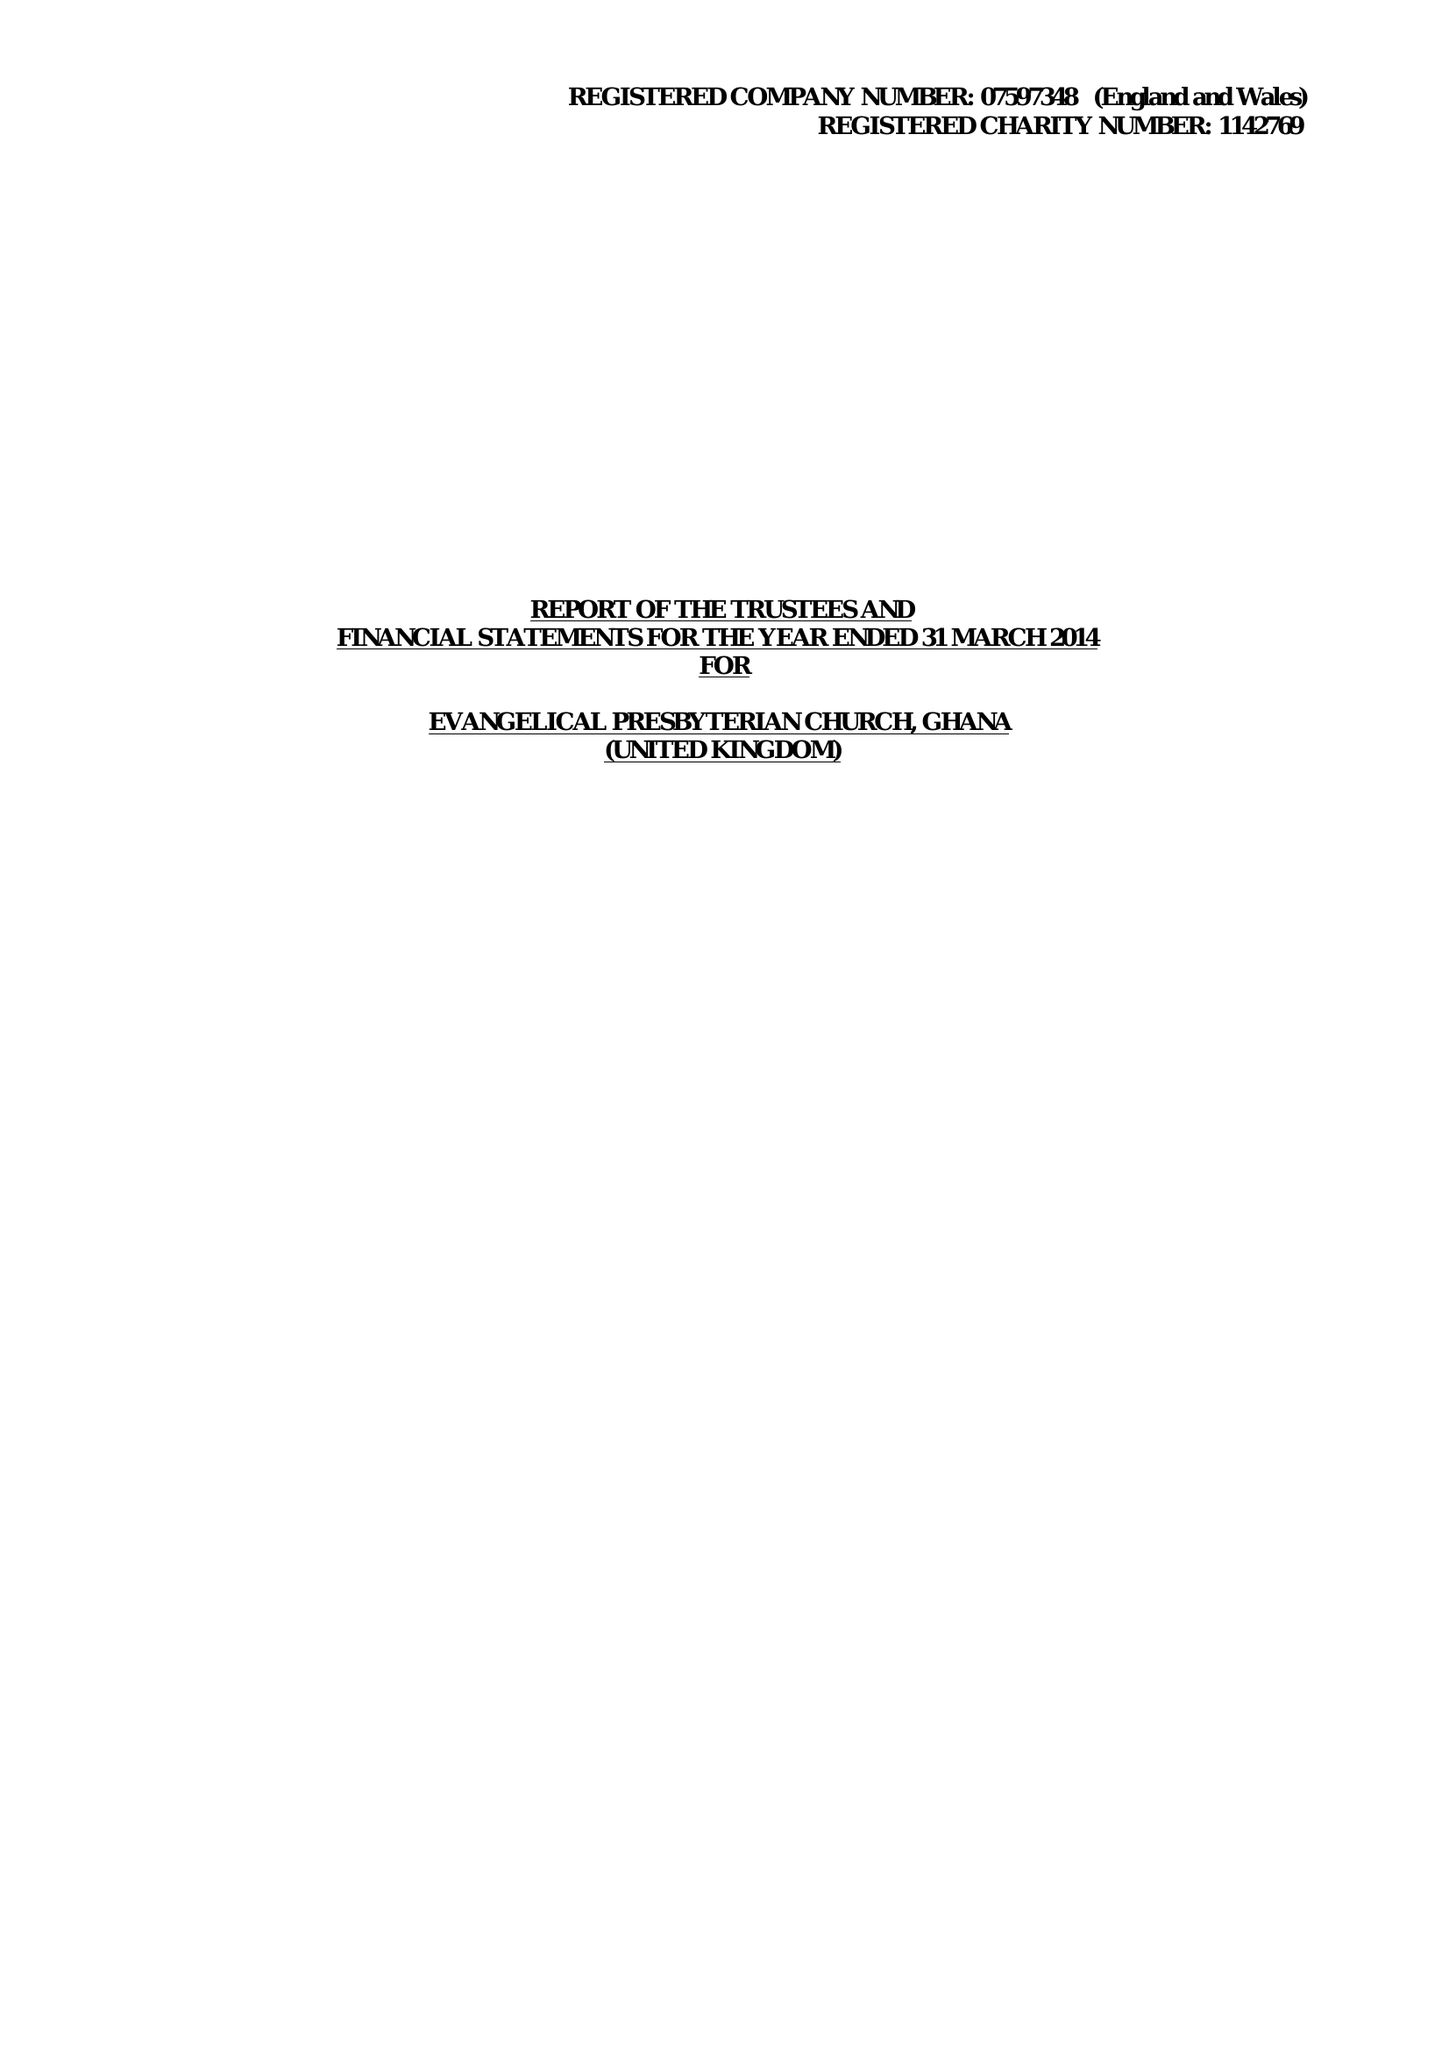What is the value for the income_annually_in_british_pounds?
Answer the question using a single word or phrase. 60721.00 